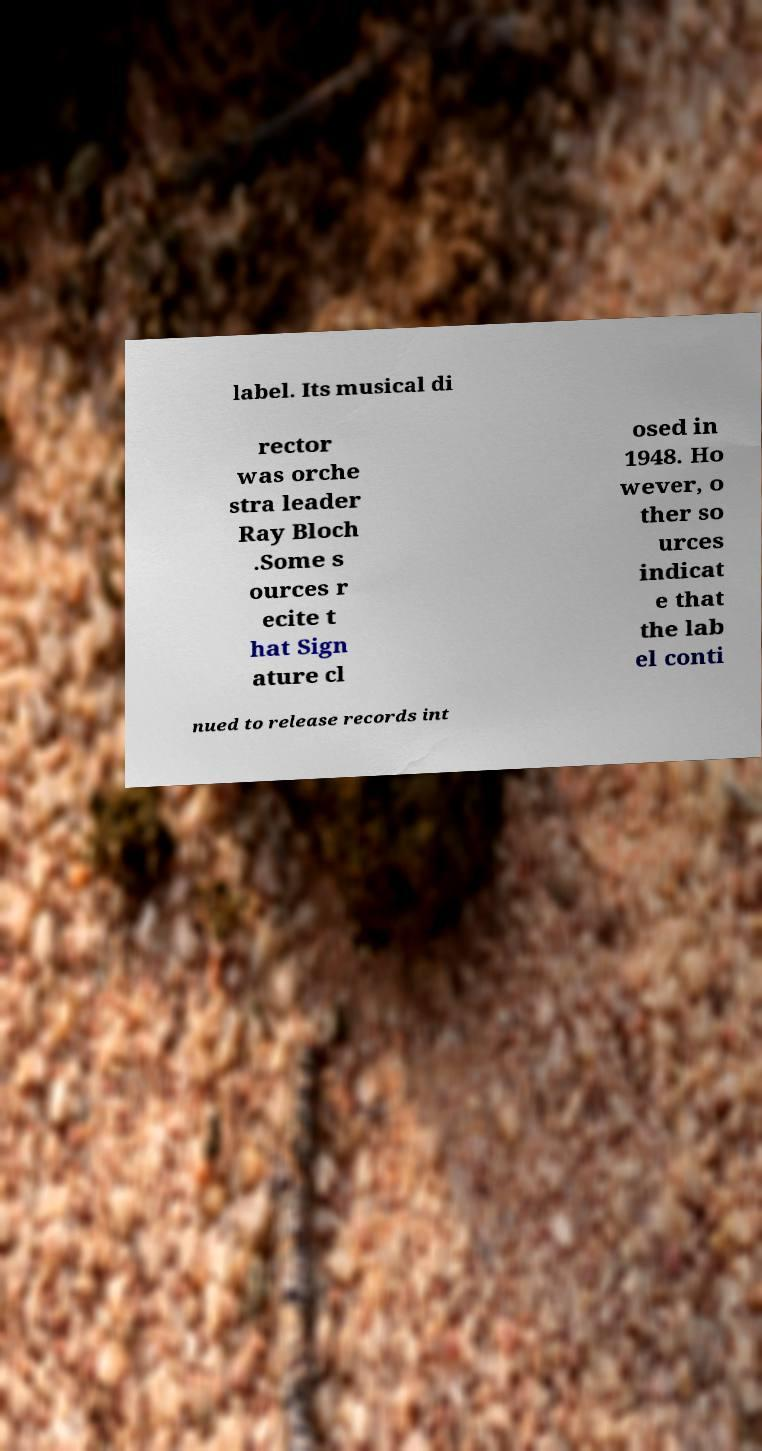Can you accurately transcribe the text from the provided image for me? label. Its musical di rector was orche stra leader Ray Bloch .Some s ources r ecite t hat Sign ature cl osed in 1948. Ho wever, o ther so urces indicat e that the lab el conti nued to release records int 